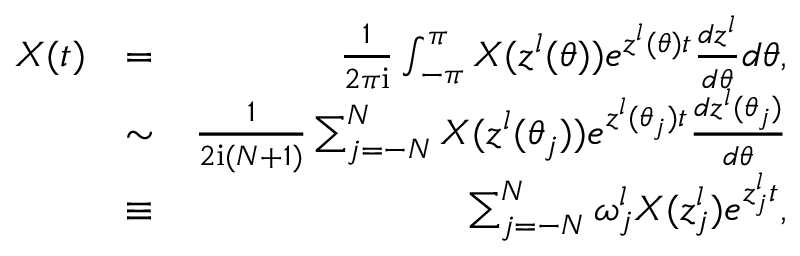<formula> <loc_0><loc_0><loc_500><loc_500>\begin{array} { r l r } { X ( t ) } & { = } & { \frac { 1 } { 2 \pi i } \int _ { - \pi } ^ { \pi } X ( z ^ { l } ( \theta ) ) e ^ { z ^ { l } ( \theta ) t } \frac { d z ^ { l } } { d \theta } d \theta , } \\ & { \sim } & { \frac { 1 } { 2 i ( N + 1 ) } \sum _ { j = - N } ^ { N } X ( z ^ { l } ( \theta _ { j } ) ) e ^ { z ^ { l } ( \theta _ { j } ) t } \frac { d z ^ { l } ( \theta _ { j } ) } { d \theta } } \\ & { \equiv } & { \sum _ { j = - N } ^ { N } \omega _ { j } ^ { l } X ( z _ { j } ^ { l } ) e ^ { z _ { j } ^ { l } t } , } \end{array}</formula> 